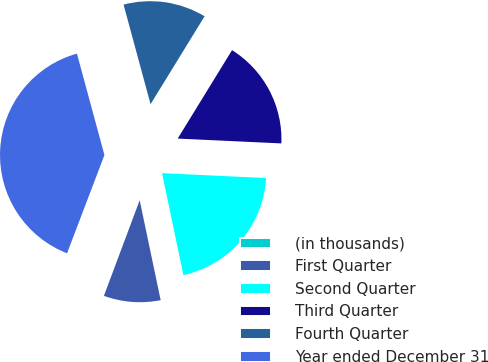Convert chart to OTSL. <chart><loc_0><loc_0><loc_500><loc_500><pie_chart><fcel>(in thousands)<fcel>First Quarter<fcel>Second Quarter<fcel>Third Quarter<fcel>Fourth Quarter<fcel>Year ended December 31<nl><fcel>0.09%<fcel>8.99%<fcel>20.96%<fcel>16.97%<fcel>12.98%<fcel>39.99%<nl></chart> 